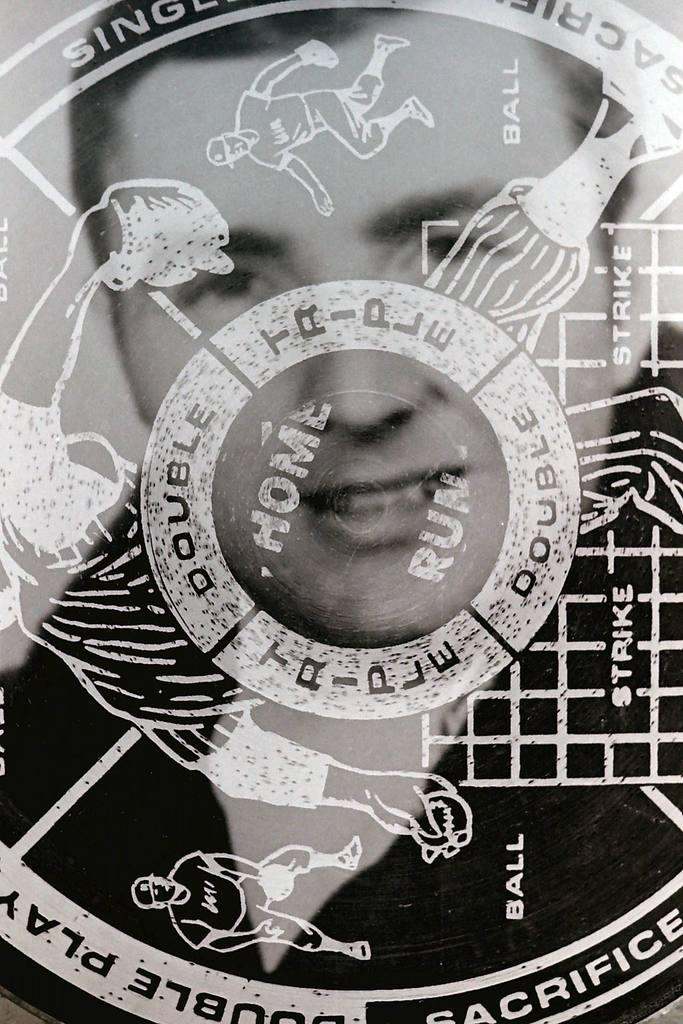What is the color scheme of the image? The image is black and white. What can be found in the middle of the image? There is a logo in the middle of the image. What is depicted within the logo? The logo contains an image of a person. Can you see any glass elements in the image? There is no glass present in the image; it is a black and white image with a logo containing an image of a person. Is there a carriage visible in the image? There is no carriage present in the image; it features a black and white logo with an image of a person. 